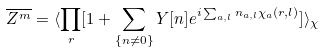Convert formula to latex. <formula><loc_0><loc_0><loc_500><loc_500>\overline { Z ^ { m } } = \langle \prod _ { r } [ 1 + \sum _ { \{ n \neq 0 \} } Y [ { n } ] e ^ { i \sum _ { a , l } n _ { a , l } \chi _ { a } ( { r } , l ) } ] \rangle _ { \chi }</formula> 